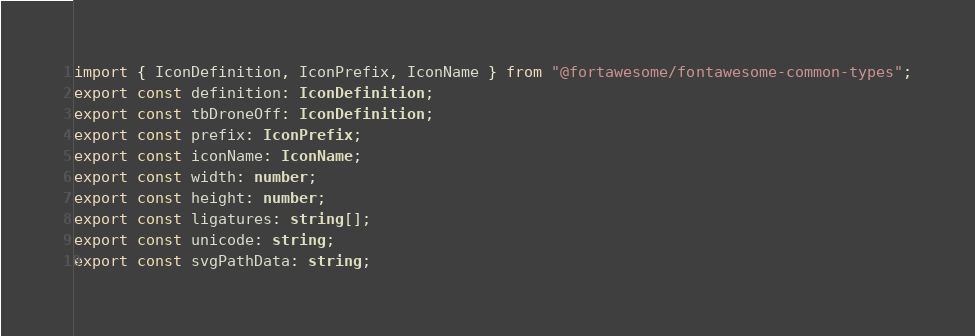Convert code to text. <code><loc_0><loc_0><loc_500><loc_500><_TypeScript_>import { IconDefinition, IconPrefix, IconName } from "@fortawesome/fontawesome-common-types";
export const definition: IconDefinition;
export const tbDroneOff: IconDefinition;
export const prefix: IconPrefix;
export const iconName: IconName;
export const width: number;
export const height: number;
export const ligatures: string[];
export const unicode: string;
export const svgPathData: string;</code> 